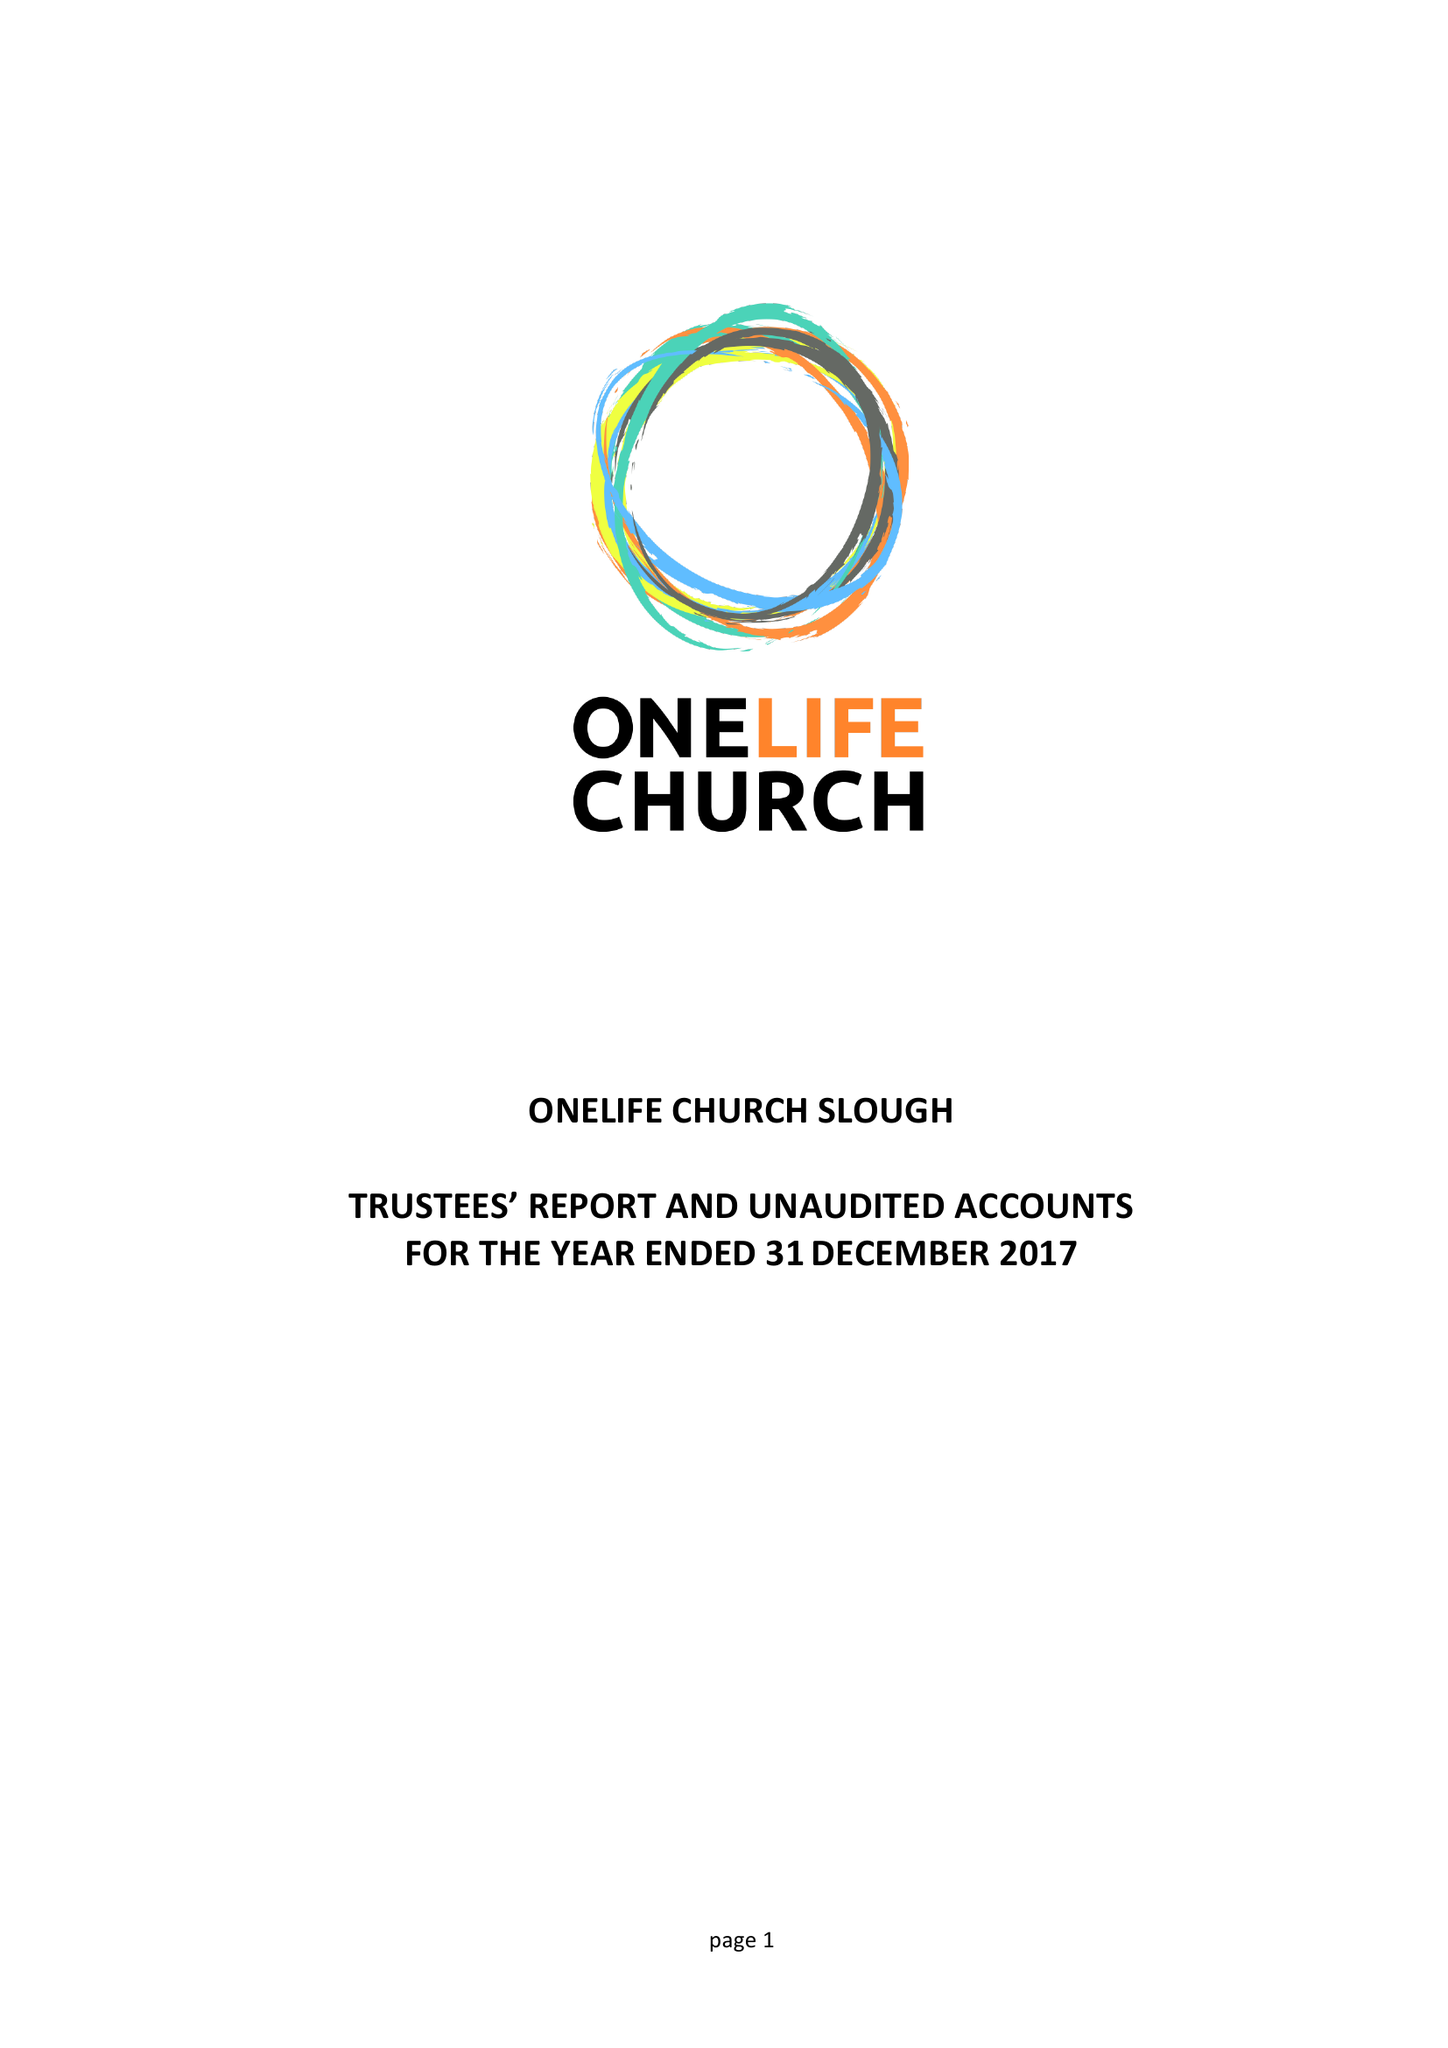What is the value for the report_date?
Answer the question using a single word or phrase. 2017-12-31 